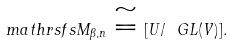Convert formula to latex. <formula><loc_0><loc_0><loc_500><loc_500>\ m a t h r s f s { M } _ { \beta , n } \cong [ U / \ G L ( V ) ] .</formula> 